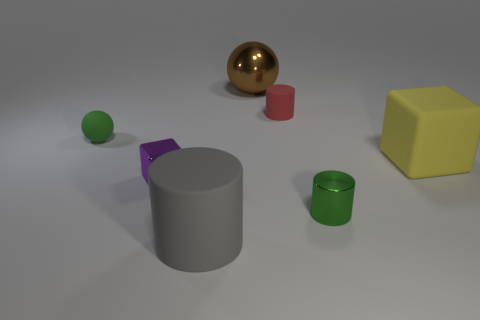How many green balls are right of the ball that is to the left of the tiny cube?
Keep it short and to the point. 0. There is a shiny thing behind the metal block; is it the same size as the rubber block?
Give a very brief answer. Yes. What number of green rubber things have the same shape as the tiny purple metal thing?
Provide a succinct answer. 0. There is a green shiny thing; what shape is it?
Ensure brevity in your answer.  Cylinder. Is the number of big yellow rubber blocks that are left of the brown object the same as the number of cyan metal objects?
Your answer should be very brief. Yes. Do the tiny sphere that is in front of the small red cylinder and the small green cylinder have the same material?
Ensure brevity in your answer.  No. Is the number of tiny things to the right of the small purple shiny cube less than the number of purple things?
Provide a succinct answer. No. What number of shiny objects are either blocks or purple things?
Your answer should be compact. 1. Is the color of the tiny ball the same as the tiny shiny cylinder?
Your response must be concise. Yes. Is there anything else that has the same color as the matte sphere?
Your response must be concise. Yes. 